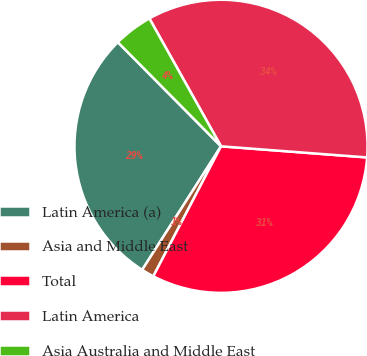Convert chart. <chart><loc_0><loc_0><loc_500><loc_500><pie_chart><fcel>Latin America (a)<fcel>Asia and Middle East<fcel>Total<fcel>Latin America<fcel>Asia Australia and Middle East<nl><fcel>28.53%<fcel>1.4%<fcel>31.43%<fcel>34.34%<fcel>4.3%<nl></chart> 